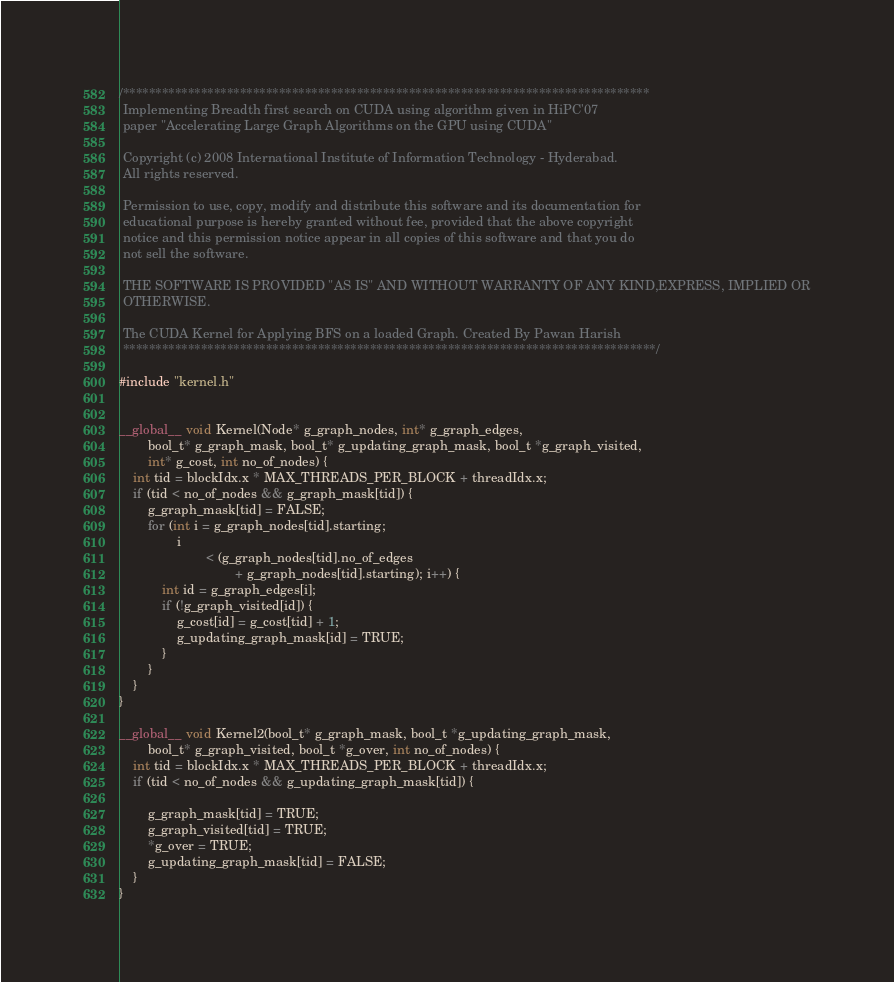Convert code to text. <code><loc_0><loc_0><loc_500><loc_500><_Cuda_>/*********************************************************************************
 Implementing Breadth first search on CUDA using algorithm given in HiPC'07
 paper "Accelerating Large Graph Algorithms on the GPU using CUDA"

 Copyright (c) 2008 International Institute of Information Technology - Hyderabad.
 All rights reserved.

 Permission to use, copy, modify and distribute this software and its documentation for
 educational purpose is hereby granted without fee, provided that the above copyright
 notice and this permission notice appear in all copies of this software and that you do
 not sell the software.

 THE SOFTWARE IS PROVIDED "AS IS" AND WITHOUT WARRANTY OF ANY KIND,EXPRESS, IMPLIED OR
 OTHERWISE.

 The CUDA Kernel for Applying BFS on a loaded Graph. Created By Pawan Harish
 **********************************************************************************/

#include "kernel.h"


__global__ void Kernel(Node* g_graph_nodes, int* g_graph_edges,
		bool_t* g_graph_mask, bool_t* g_updating_graph_mask, bool_t *g_graph_visited,
		int* g_cost, int no_of_nodes) {
	int tid = blockIdx.x * MAX_THREADS_PER_BLOCK + threadIdx.x;
	if (tid < no_of_nodes && g_graph_mask[tid]) {
		g_graph_mask[tid] = FALSE;
		for (int i = g_graph_nodes[tid].starting;
				i
						< (g_graph_nodes[tid].no_of_edges
								+ g_graph_nodes[tid].starting); i++) {
			int id = g_graph_edges[i];
			if (!g_graph_visited[id]) {
				g_cost[id] = g_cost[tid] + 1;
				g_updating_graph_mask[id] = TRUE;
			}
		}
	}
}

__global__ void Kernel2(bool_t* g_graph_mask, bool_t *g_updating_graph_mask,
		bool_t* g_graph_visited, bool_t *g_over, int no_of_nodes) {
	int tid = blockIdx.x * MAX_THREADS_PER_BLOCK + threadIdx.x;
	if (tid < no_of_nodes && g_updating_graph_mask[tid]) {

		g_graph_mask[tid] = TRUE;
		g_graph_visited[tid] = TRUE;
		*g_over = TRUE;
		g_updating_graph_mask[tid] = FALSE;
	}
}

</code> 